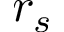Convert formula to latex. <formula><loc_0><loc_0><loc_500><loc_500>r _ { s }</formula> 